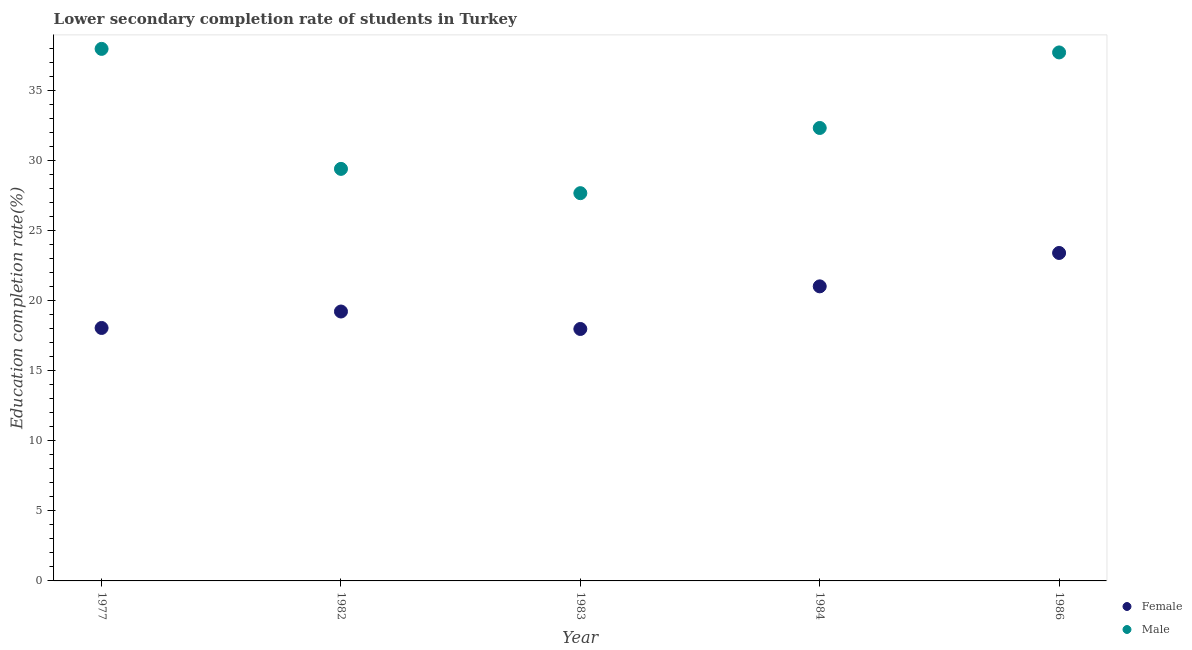What is the education completion rate of female students in 1986?
Make the answer very short. 23.4. Across all years, what is the maximum education completion rate of male students?
Ensure brevity in your answer.  37.97. Across all years, what is the minimum education completion rate of female students?
Provide a succinct answer. 17.98. What is the total education completion rate of female students in the graph?
Ensure brevity in your answer.  99.69. What is the difference between the education completion rate of female students in 1977 and that in 1982?
Your answer should be compact. -1.17. What is the difference between the education completion rate of female students in 1977 and the education completion rate of male students in 1986?
Make the answer very short. -19.66. What is the average education completion rate of female students per year?
Provide a succinct answer. 19.94. In the year 1982, what is the difference between the education completion rate of male students and education completion rate of female students?
Provide a succinct answer. 10.18. What is the ratio of the education completion rate of male students in 1984 to that in 1986?
Keep it short and to the point. 0.86. Is the difference between the education completion rate of male students in 1977 and 1984 greater than the difference between the education completion rate of female students in 1977 and 1984?
Offer a very short reply. Yes. What is the difference between the highest and the second highest education completion rate of male students?
Provide a succinct answer. 0.25. What is the difference between the highest and the lowest education completion rate of male students?
Your response must be concise. 10.3. In how many years, is the education completion rate of male students greater than the average education completion rate of male students taken over all years?
Keep it short and to the point. 2. Is the sum of the education completion rate of female students in 1984 and 1986 greater than the maximum education completion rate of male students across all years?
Provide a short and direct response. Yes. Does the education completion rate of female students monotonically increase over the years?
Ensure brevity in your answer.  No. Is the education completion rate of female students strictly greater than the education completion rate of male students over the years?
Offer a very short reply. No. Is the education completion rate of female students strictly less than the education completion rate of male students over the years?
Provide a short and direct response. Yes. How many years are there in the graph?
Offer a terse response. 5. Does the graph contain grids?
Ensure brevity in your answer.  No. Where does the legend appear in the graph?
Offer a very short reply. Bottom right. How many legend labels are there?
Keep it short and to the point. 2. How are the legend labels stacked?
Keep it short and to the point. Vertical. What is the title of the graph?
Give a very brief answer. Lower secondary completion rate of students in Turkey. What is the label or title of the Y-axis?
Your answer should be compact. Education completion rate(%). What is the Education completion rate(%) of Female in 1977?
Give a very brief answer. 18.05. What is the Education completion rate(%) of Male in 1977?
Offer a terse response. 37.97. What is the Education completion rate(%) in Female in 1982?
Ensure brevity in your answer.  19.23. What is the Education completion rate(%) in Male in 1982?
Your answer should be very brief. 29.41. What is the Education completion rate(%) of Female in 1983?
Provide a succinct answer. 17.98. What is the Education completion rate(%) of Male in 1983?
Provide a succinct answer. 27.67. What is the Education completion rate(%) of Female in 1984?
Your answer should be compact. 21.02. What is the Education completion rate(%) of Male in 1984?
Provide a succinct answer. 32.33. What is the Education completion rate(%) in Female in 1986?
Offer a terse response. 23.4. What is the Education completion rate(%) in Male in 1986?
Your answer should be compact. 37.72. Across all years, what is the maximum Education completion rate(%) of Female?
Keep it short and to the point. 23.4. Across all years, what is the maximum Education completion rate(%) of Male?
Make the answer very short. 37.97. Across all years, what is the minimum Education completion rate(%) in Female?
Offer a terse response. 17.98. Across all years, what is the minimum Education completion rate(%) of Male?
Offer a terse response. 27.67. What is the total Education completion rate(%) in Female in the graph?
Make the answer very short. 99.69. What is the total Education completion rate(%) in Male in the graph?
Your answer should be compact. 165.09. What is the difference between the Education completion rate(%) of Female in 1977 and that in 1982?
Offer a terse response. -1.17. What is the difference between the Education completion rate(%) of Male in 1977 and that in 1982?
Keep it short and to the point. 8.56. What is the difference between the Education completion rate(%) in Female in 1977 and that in 1983?
Offer a very short reply. 0.07. What is the difference between the Education completion rate(%) in Male in 1977 and that in 1983?
Provide a succinct answer. 10.3. What is the difference between the Education completion rate(%) in Female in 1977 and that in 1984?
Provide a succinct answer. -2.97. What is the difference between the Education completion rate(%) of Male in 1977 and that in 1984?
Provide a succinct answer. 5.64. What is the difference between the Education completion rate(%) of Female in 1977 and that in 1986?
Ensure brevity in your answer.  -5.35. What is the difference between the Education completion rate(%) of Male in 1977 and that in 1986?
Your response must be concise. 0.25. What is the difference between the Education completion rate(%) in Female in 1982 and that in 1983?
Offer a terse response. 1.25. What is the difference between the Education completion rate(%) of Male in 1982 and that in 1983?
Your answer should be compact. 1.73. What is the difference between the Education completion rate(%) in Female in 1982 and that in 1984?
Make the answer very short. -1.8. What is the difference between the Education completion rate(%) in Male in 1982 and that in 1984?
Provide a short and direct response. -2.92. What is the difference between the Education completion rate(%) of Female in 1982 and that in 1986?
Make the answer very short. -4.18. What is the difference between the Education completion rate(%) of Male in 1982 and that in 1986?
Provide a succinct answer. -8.31. What is the difference between the Education completion rate(%) of Female in 1983 and that in 1984?
Your response must be concise. -3.04. What is the difference between the Education completion rate(%) in Male in 1983 and that in 1984?
Provide a short and direct response. -4.65. What is the difference between the Education completion rate(%) of Female in 1983 and that in 1986?
Keep it short and to the point. -5.42. What is the difference between the Education completion rate(%) of Male in 1983 and that in 1986?
Provide a succinct answer. -10.04. What is the difference between the Education completion rate(%) in Female in 1984 and that in 1986?
Keep it short and to the point. -2.38. What is the difference between the Education completion rate(%) in Male in 1984 and that in 1986?
Keep it short and to the point. -5.39. What is the difference between the Education completion rate(%) of Female in 1977 and the Education completion rate(%) of Male in 1982?
Your answer should be very brief. -11.35. What is the difference between the Education completion rate(%) in Female in 1977 and the Education completion rate(%) in Male in 1983?
Make the answer very short. -9.62. What is the difference between the Education completion rate(%) of Female in 1977 and the Education completion rate(%) of Male in 1984?
Ensure brevity in your answer.  -14.27. What is the difference between the Education completion rate(%) in Female in 1977 and the Education completion rate(%) in Male in 1986?
Offer a very short reply. -19.66. What is the difference between the Education completion rate(%) in Female in 1982 and the Education completion rate(%) in Male in 1983?
Keep it short and to the point. -8.45. What is the difference between the Education completion rate(%) in Female in 1982 and the Education completion rate(%) in Male in 1984?
Provide a short and direct response. -13.1. What is the difference between the Education completion rate(%) of Female in 1982 and the Education completion rate(%) of Male in 1986?
Give a very brief answer. -18.49. What is the difference between the Education completion rate(%) in Female in 1983 and the Education completion rate(%) in Male in 1984?
Ensure brevity in your answer.  -14.35. What is the difference between the Education completion rate(%) of Female in 1983 and the Education completion rate(%) of Male in 1986?
Provide a succinct answer. -19.74. What is the difference between the Education completion rate(%) in Female in 1984 and the Education completion rate(%) in Male in 1986?
Provide a short and direct response. -16.69. What is the average Education completion rate(%) in Female per year?
Keep it short and to the point. 19.94. What is the average Education completion rate(%) of Male per year?
Keep it short and to the point. 33.02. In the year 1977, what is the difference between the Education completion rate(%) of Female and Education completion rate(%) of Male?
Your answer should be very brief. -19.92. In the year 1982, what is the difference between the Education completion rate(%) of Female and Education completion rate(%) of Male?
Provide a short and direct response. -10.18. In the year 1983, what is the difference between the Education completion rate(%) of Female and Education completion rate(%) of Male?
Your answer should be very brief. -9.69. In the year 1984, what is the difference between the Education completion rate(%) of Female and Education completion rate(%) of Male?
Provide a succinct answer. -11.3. In the year 1986, what is the difference between the Education completion rate(%) of Female and Education completion rate(%) of Male?
Your answer should be very brief. -14.31. What is the ratio of the Education completion rate(%) of Female in 1977 to that in 1982?
Your answer should be compact. 0.94. What is the ratio of the Education completion rate(%) of Male in 1977 to that in 1982?
Offer a very short reply. 1.29. What is the ratio of the Education completion rate(%) in Female in 1977 to that in 1983?
Your response must be concise. 1. What is the ratio of the Education completion rate(%) of Male in 1977 to that in 1983?
Give a very brief answer. 1.37. What is the ratio of the Education completion rate(%) of Female in 1977 to that in 1984?
Make the answer very short. 0.86. What is the ratio of the Education completion rate(%) of Male in 1977 to that in 1984?
Give a very brief answer. 1.17. What is the ratio of the Education completion rate(%) of Female in 1977 to that in 1986?
Provide a succinct answer. 0.77. What is the ratio of the Education completion rate(%) of Male in 1977 to that in 1986?
Offer a terse response. 1.01. What is the ratio of the Education completion rate(%) of Female in 1982 to that in 1983?
Your answer should be compact. 1.07. What is the ratio of the Education completion rate(%) in Male in 1982 to that in 1983?
Provide a short and direct response. 1.06. What is the ratio of the Education completion rate(%) of Female in 1982 to that in 1984?
Ensure brevity in your answer.  0.91. What is the ratio of the Education completion rate(%) of Male in 1982 to that in 1984?
Give a very brief answer. 0.91. What is the ratio of the Education completion rate(%) of Female in 1982 to that in 1986?
Provide a succinct answer. 0.82. What is the ratio of the Education completion rate(%) in Male in 1982 to that in 1986?
Make the answer very short. 0.78. What is the ratio of the Education completion rate(%) of Female in 1983 to that in 1984?
Provide a succinct answer. 0.86. What is the ratio of the Education completion rate(%) in Male in 1983 to that in 1984?
Your response must be concise. 0.86. What is the ratio of the Education completion rate(%) of Female in 1983 to that in 1986?
Give a very brief answer. 0.77. What is the ratio of the Education completion rate(%) of Male in 1983 to that in 1986?
Ensure brevity in your answer.  0.73. What is the ratio of the Education completion rate(%) of Female in 1984 to that in 1986?
Provide a succinct answer. 0.9. What is the ratio of the Education completion rate(%) in Male in 1984 to that in 1986?
Provide a succinct answer. 0.86. What is the difference between the highest and the second highest Education completion rate(%) of Female?
Provide a succinct answer. 2.38. What is the difference between the highest and the second highest Education completion rate(%) in Male?
Offer a terse response. 0.25. What is the difference between the highest and the lowest Education completion rate(%) of Female?
Offer a very short reply. 5.42. What is the difference between the highest and the lowest Education completion rate(%) of Male?
Ensure brevity in your answer.  10.3. 